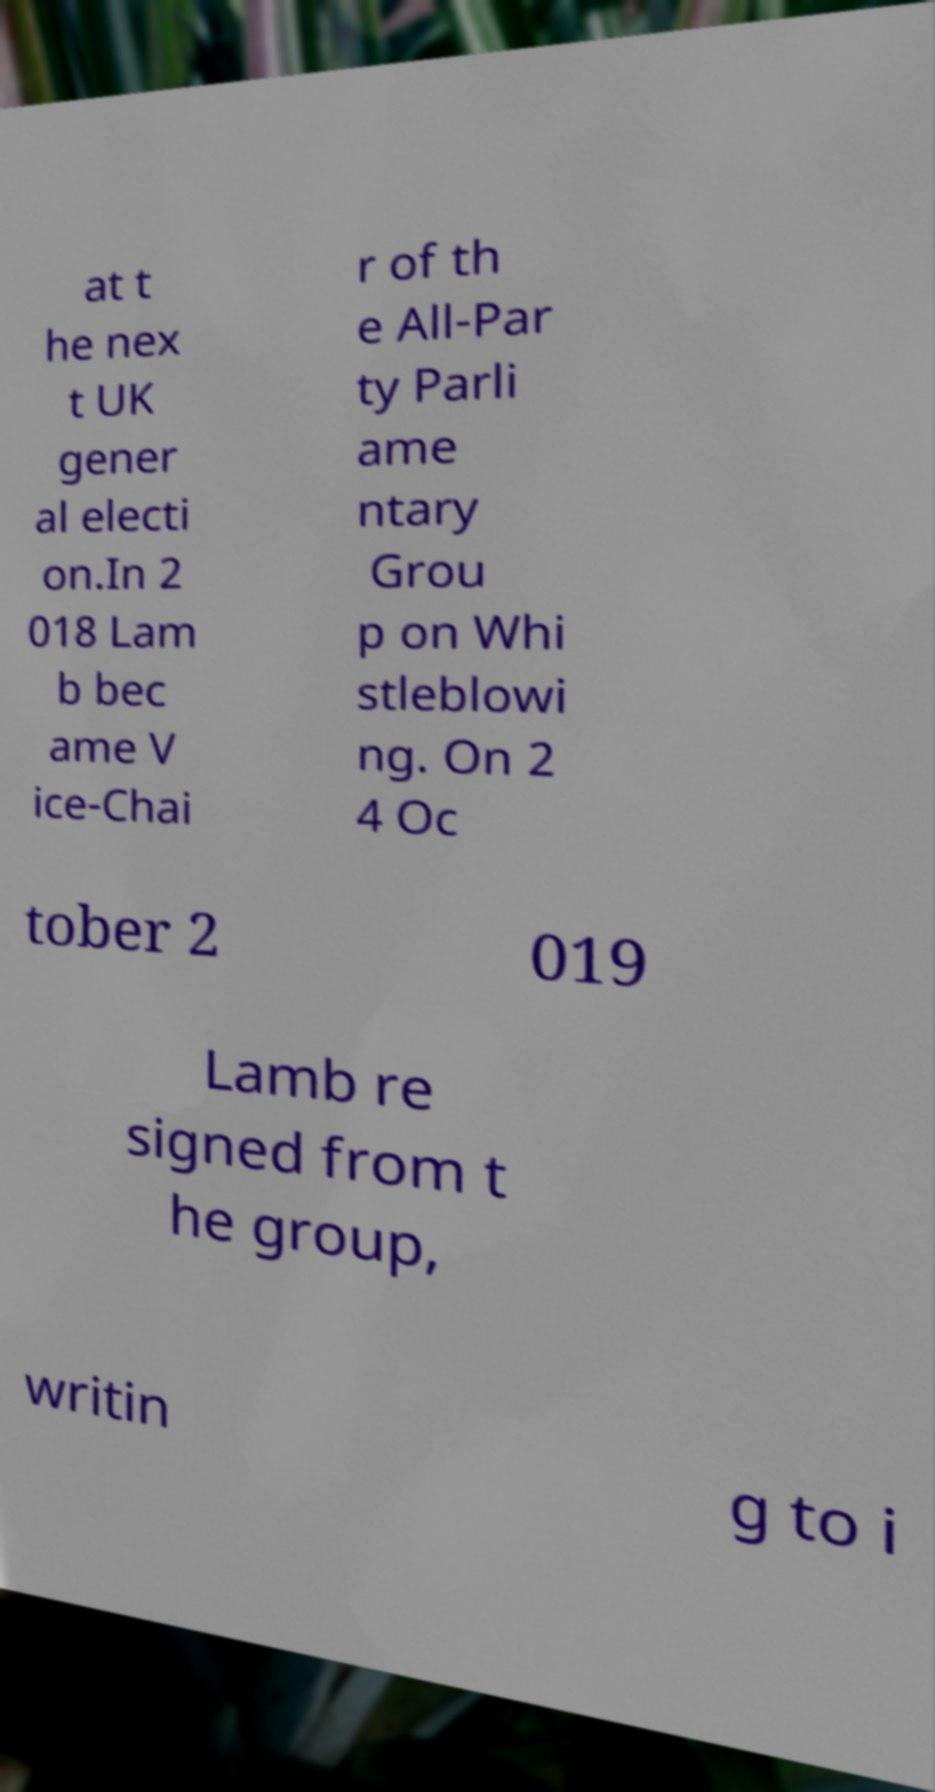For documentation purposes, I need the text within this image transcribed. Could you provide that? at t he nex t UK gener al electi on.In 2 018 Lam b bec ame V ice-Chai r of th e All-Par ty Parli ame ntary Grou p on Whi stleblowi ng. On 2 4 Oc tober 2 019 Lamb re signed from t he group, writin g to i 